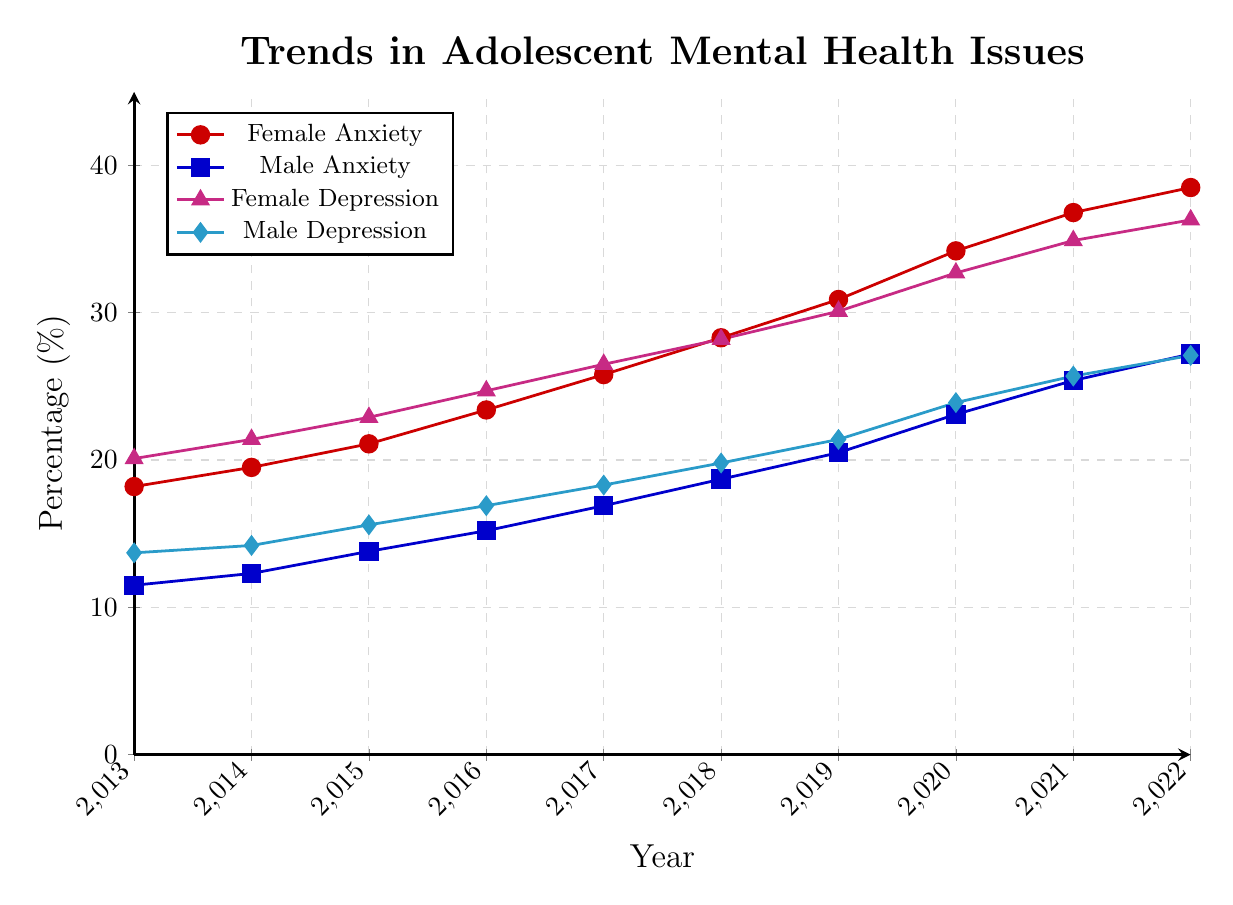What is the trend of female anxiety from 2013 to 2022? To determine the trend, look at the values of female anxiety across the years from 2013 to 2022. Notice that the values are increasing over time.
Answer: Increasing In which year did male depression first reach a value higher than 20%? Identify the values for male depression in each year and find the first year it exceeds 20%. In 2019, the value reaches 21.4%, which is the first time it surpasses 20%.
Answer: 2019 By how much did female depression increase from 2013 to 2022? Subtract the value of female depression in 2013 from the value of female depression in 2022. The values are 36.3% in 2022 and 20.1% in 2013. So, the increase is 36.3 - 20.1.
Answer: 16.2% Compare the trends of female anxiety and male anxiety from 2013 to 2022. Examine the values for both female and male anxiety over the years. Both lines are increasing, but the rate of increase and the starting and ending values are different. Female anxiety starts at 18.2% and goes up to 38.5%, while male anxiety starts at 11.5% and goes up to 27.2%.
Answer: Both are increasing, female anxiety increases at a higher rate Between 2016 and 2018, which gender saw a higher increase in depression? Calculate the difference in depression values for 2016 and 2018 for both genders. Female depression went from 24.7% to 28.2%, which is an increase of 3.5%. Male depression went from 16.9% to 19.8%, an increase of 2.9%.
Answer: Female What is the average percentage of male anxiety between 2015 and 2020? Add the values of male anxiety for 2015, 2016, 2017, 2018, 2019, and 2020 and divide by the number of years (6). Values are 13.8, 15.2, 16.9, 18.7, 20.5, and 23.1. The total is 108.2, so the average is 108.2 / 6.
Answer: 18.03% What is the percentage difference between female depression and male depression in 2022? Subtract the male depression percentage for 2022 from the female depression percentage for 2022. The values are 36.3% for females and 27.1% for males. So, the difference is 36.3 - 27.1.
Answer: 9.2% Which year shows the steepest increase in female anxiety? To find the steepest increase, look at the year-over-year differences for female anxiety. The largest difference is between 2019 (30.9) and 2020 (34.2), which is an increase of 3.3%.
Answer: 2019 to 2020 Is there any year where male anxiety and male depression are equal? Compare the values of male anxiety and male depression for each year. There is no year where these values are the same; the values are always different.
Answer: No 